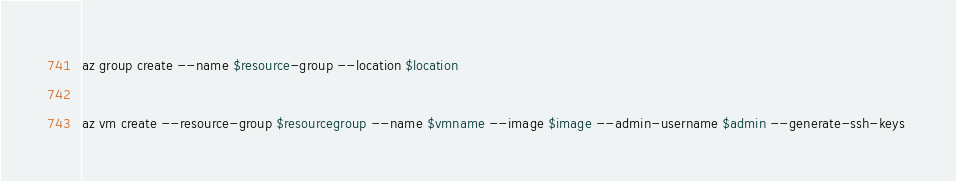<code> <loc_0><loc_0><loc_500><loc_500><_Bash_>az group create --name $resource-group --location $location

az vm create --resource-group $resourcegroup --name $vmname --image $image --admin-username $admin --generate-ssh-keys 
</code> 